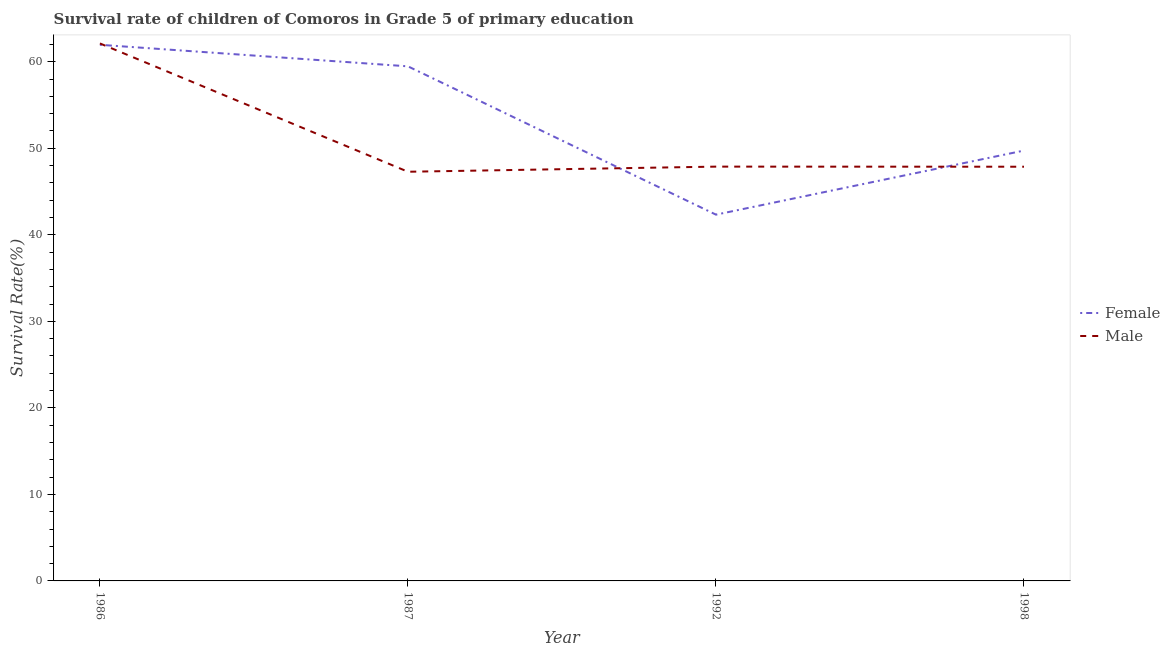Is the number of lines equal to the number of legend labels?
Give a very brief answer. Yes. What is the survival rate of male students in primary education in 1986?
Offer a terse response. 62.11. Across all years, what is the maximum survival rate of female students in primary education?
Your answer should be very brief. 61.96. Across all years, what is the minimum survival rate of male students in primary education?
Keep it short and to the point. 47.29. In which year was the survival rate of male students in primary education maximum?
Your answer should be very brief. 1986. In which year was the survival rate of male students in primary education minimum?
Offer a terse response. 1987. What is the total survival rate of male students in primary education in the graph?
Offer a terse response. 205.14. What is the difference between the survival rate of male students in primary education in 1986 and that in 1992?
Your answer should be very brief. 14.24. What is the difference between the survival rate of female students in primary education in 1986 and the survival rate of male students in primary education in 1998?
Provide a short and direct response. 14.09. What is the average survival rate of male students in primary education per year?
Your answer should be compact. 51.29. In the year 1986, what is the difference between the survival rate of female students in primary education and survival rate of male students in primary education?
Provide a short and direct response. -0.16. What is the ratio of the survival rate of female students in primary education in 1987 to that in 1998?
Your answer should be very brief. 1.2. Is the survival rate of male students in primary education in 1986 less than that in 1992?
Offer a very short reply. No. Is the difference between the survival rate of male students in primary education in 1986 and 1987 greater than the difference between the survival rate of female students in primary education in 1986 and 1987?
Give a very brief answer. Yes. What is the difference between the highest and the second highest survival rate of female students in primary education?
Your answer should be very brief. 2.49. What is the difference between the highest and the lowest survival rate of female students in primary education?
Your answer should be very brief. 19.63. In how many years, is the survival rate of male students in primary education greater than the average survival rate of male students in primary education taken over all years?
Keep it short and to the point. 1. Is the sum of the survival rate of female students in primary education in 1986 and 1987 greater than the maximum survival rate of male students in primary education across all years?
Offer a terse response. Yes. Does the survival rate of female students in primary education monotonically increase over the years?
Your answer should be very brief. No. Is the survival rate of male students in primary education strictly less than the survival rate of female students in primary education over the years?
Provide a succinct answer. No. What is the difference between two consecutive major ticks on the Y-axis?
Ensure brevity in your answer.  10. Does the graph contain any zero values?
Your answer should be very brief. No. Does the graph contain grids?
Keep it short and to the point. No. How many legend labels are there?
Make the answer very short. 2. How are the legend labels stacked?
Offer a very short reply. Vertical. What is the title of the graph?
Offer a terse response. Survival rate of children of Comoros in Grade 5 of primary education. Does "Investment in Transport" appear as one of the legend labels in the graph?
Ensure brevity in your answer.  No. What is the label or title of the Y-axis?
Keep it short and to the point. Survival Rate(%). What is the Survival Rate(%) of Female in 1986?
Ensure brevity in your answer.  61.96. What is the Survival Rate(%) of Male in 1986?
Your response must be concise. 62.11. What is the Survival Rate(%) of Female in 1987?
Offer a very short reply. 59.47. What is the Survival Rate(%) in Male in 1987?
Your response must be concise. 47.29. What is the Survival Rate(%) in Female in 1992?
Offer a terse response. 42.33. What is the Survival Rate(%) in Male in 1992?
Keep it short and to the point. 47.88. What is the Survival Rate(%) in Female in 1998?
Keep it short and to the point. 49.73. What is the Survival Rate(%) in Male in 1998?
Make the answer very short. 47.87. Across all years, what is the maximum Survival Rate(%) of Female?
Provide a succinct answer. 61.96. Across all years, what is the maximum Survival Rate(%) of Male?
Keep it short and to the point. 62.11. Across all years, what is the minimum Survival Rate(%) of Female?
Make the answer very short. 42.33. Across all years, what is the minimum Survival Rate(%) of Male?
Your response must be concise. 47.29. What is the total Survival Rate(%) of Female in the graph?
Provide a succinct answer. 213.49. What is the total Survival Rate(%) in Male in the graph?
Make the answer very short. 205.14. What is the difference between the Survival Rate(%) of Female in 1986 and that in 1987?
Keep it short and to the point. 2.49. What is the difference between the Survival Rate(%) of Male in 1986 and that in 1987?
Make the answer very short. 14.83. What is the difference between the Survival Rate(%) of Female in 1986 and that in 1992?
Your response must be concise. 19.63. What is the difference between the Survival Rate(%) of Male in 1986 and that in 1992?
Provide a succinct answer. 14.24. What is the difference between the Survival Rate(%) of Female in 1986 and that in 1998?
Give a very brief answer. 12.22. What is the difference between the Survival Rate(%) of Male in 1986 and that in 1998?
Keep it short and to the point. 14.25. What is the difference between the Survival Rate(%) in Female in 1987 and that in 1992?
Give a very brief answer. 17.14. What is the difference between the Survival Rate(%) in Male in 1987 and that in 1992?
Offer a very short reply. -0.59. What is the difference between the Survival Rate(%) of Female in 1987 and that in 1998?
Keep it short and to the point. 9.73. What is the difference between the Survival Rate(%) of Male in 1987 and that in 1998?
Make the answer very short. -0.58. What is the difference between the Survival Rate(%) of Female in 1992 and that in 1998?
Provide a succinct answer. -7.41. What is the difference between the Survival Rate(%) in Male in 1992 and that in 1998?
Keep it short and to the point. 0.01. What is the difference between the Survival Rate(%) in Female in 1986 and the Survival Rate(%) in Male in 1987?
Keep it short and to the point. 14.67. What is the difference between the Survival Rate(%) in Female in 1986 and the Survival Rate(%) in Male in 1992?
Keep it short and to the point. 14.08. What is the difference between the Survival Rate(%) in Female in 1986 and the Survival Rate(%) in Male in 1998?
Provide a short and direct response. 14.09. What is the difference between the Survival Rate(%) of Female in 1987 and the Survival Rate(%) of Male in 1992?
Your answer should be very brief. 11.59. What is the difference between the Survival Rate(%) of Female in 1987 and the Survival Rate(%) of Male in 1998?
Provide a short and direct response. 11.6. What is the difference between the Survival Rate(%) in Female in 1992 and the Survival Rate(%) in Male in 1998?
Provide a succinct answer. -5.54. What is the average Survival Rate(%) in Female per year?
Your answer should be very brief. 53.37. What is the average Survival Rate(%) in Male per year?
Make the answer very short. 51.29. In the year 1986, what is the difference between the Survival Rate(%) of Female and Survival Rate(%) of Male?
Offer a terse response. -0.16. In the year 1987, what is the difference between the Survival Rate(%) in Female and Survival Rate(%) in Male?
Provide a succinct answer. 12.18. In the year 1992, what is the difference between the Survival Rate(%) of Female and Survival Rate(%) of Male?
Provide a succinct answer. -5.55. In the year 1998, what is the difference between the Survival Rate(%) in Female and Survival Rate(%) in Male?
Your response must be concise. 1.87. What is the ratio of the Survival Rate(%) of Female in 1986 to that in 1987?
Your answer should be very brief. 1.04. What is the ratio of the Survival Rate(%) of Male in 1986 to that in 1987?
Ensure brevity in your answer.  1.31. What is the ratio of the Survival Rate(%) in Female in 1986 to that in 1992?
Keep it short and to the point. 1.46. What is the ratio of the Survival Rate(%) in Male in 1986 to that in 1992?
Offer a very short reply. 1.3. What is the ratio of the Survival Rate(%) in Female in 1986 to that in 1998?
Offer a very short reply. 1.25. What is the ratio of the Survival Rate(%) of Male in 1986 to that in 1998?
Offer a terse response. 1.3. What is the ratio of the Survival Rate(%) of Female in 1987 to that in 1992?
Your answer should be very brief. 1.4. What is the ratio of the Survival Rate(%) of Male in 1987 to that in 1992?
Offer a very short reply. 0.99. What is the ratio of the Survival Rate(%) in Female in 1987 to that in 1998?
Keep it short and to the point. 1.2. What is the ratio of the Survival Rate(%) in Male in 1987 to that in 1998?
Offer a very short reply. 0.99. What is the ratio of the Survival Rate(%) of Female in 1992 to that in 1998?
Provide a succinct answer. 0.85. What is the difference between the highest and the second highest Survival Rate(%) of Female?
Make the answer very short. 2.49. What is the difference between the highest and the second highest Survival Rate(%) in Male?
Provide a succinct answer. 14.24. What is the difference between the highest and the lowest Survival Rate(%) in Female?
Provide a short and direct response. 19.63. What is the difference between the highest and the lowest Survival Rate(%) of Male?
Keep it short and to the point. 14.83. 